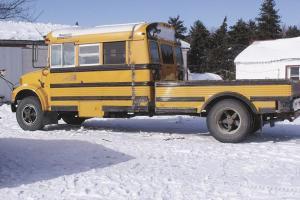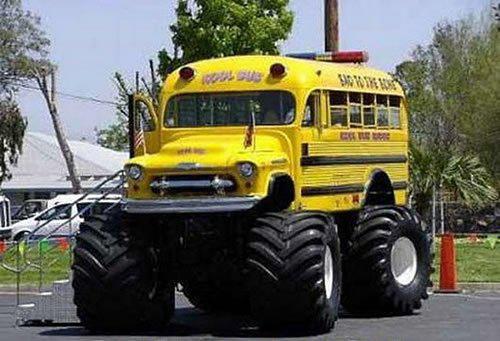The first image is the image on the left, the second image is the image on the right. Examine the images to the left and right. Is the description "People are getting on the bus." accurate? Answer yes or no. No. The first image is the image on the left, the second image is the image on the right. Evaluate the accuracy of this statement regarding the images: "A child is entering the open door of a school bus parked at a rightward angle in one image, and the other image shows a leftward angled bus.". Is it true? Answer yes or no. No. 